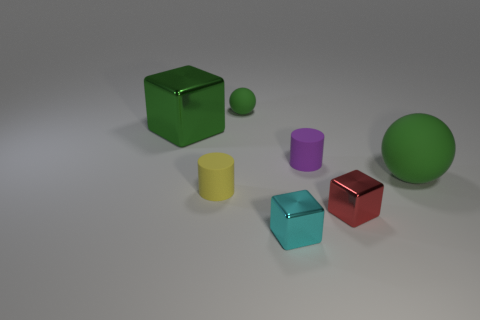What is the size of the rubber thing that is the same color as the large sphere?
Offer a very short reply. Small. What is the color of the tiny sphere?
Give a very brief answer. Green. There is a large object in front of the tiny purple thing; is it the same shape as the small green rubber object?
Offer a terse response. Yes. The green rubber object in front of the thing on the left side of the matte cylinder that is to the left of the tiny cyan cube is what shape?
Keep it short and to the point. Sphere. There is a small thing behind the green block; what material is it?
Provide a short and direct response. Rubber. There is another block that is the same size as the red shiny block; what color is it?
Give a very brief answer. Cyan. What number of other things are the same shape as the yellow rubber object?
Give a very brief answer. 1. Do the yellow cylinder and the cyan shiny cube have the same size?
Your answer should be compact. Yes. Are there more cyan cubes in front of the tiny red object than purple matte objects on the right side of the purple matte cylinder?
Provide a succinct answer. Yes. How many other things are there of the same size as the purple rubber cylinder?
Make the answer very short. 4. 